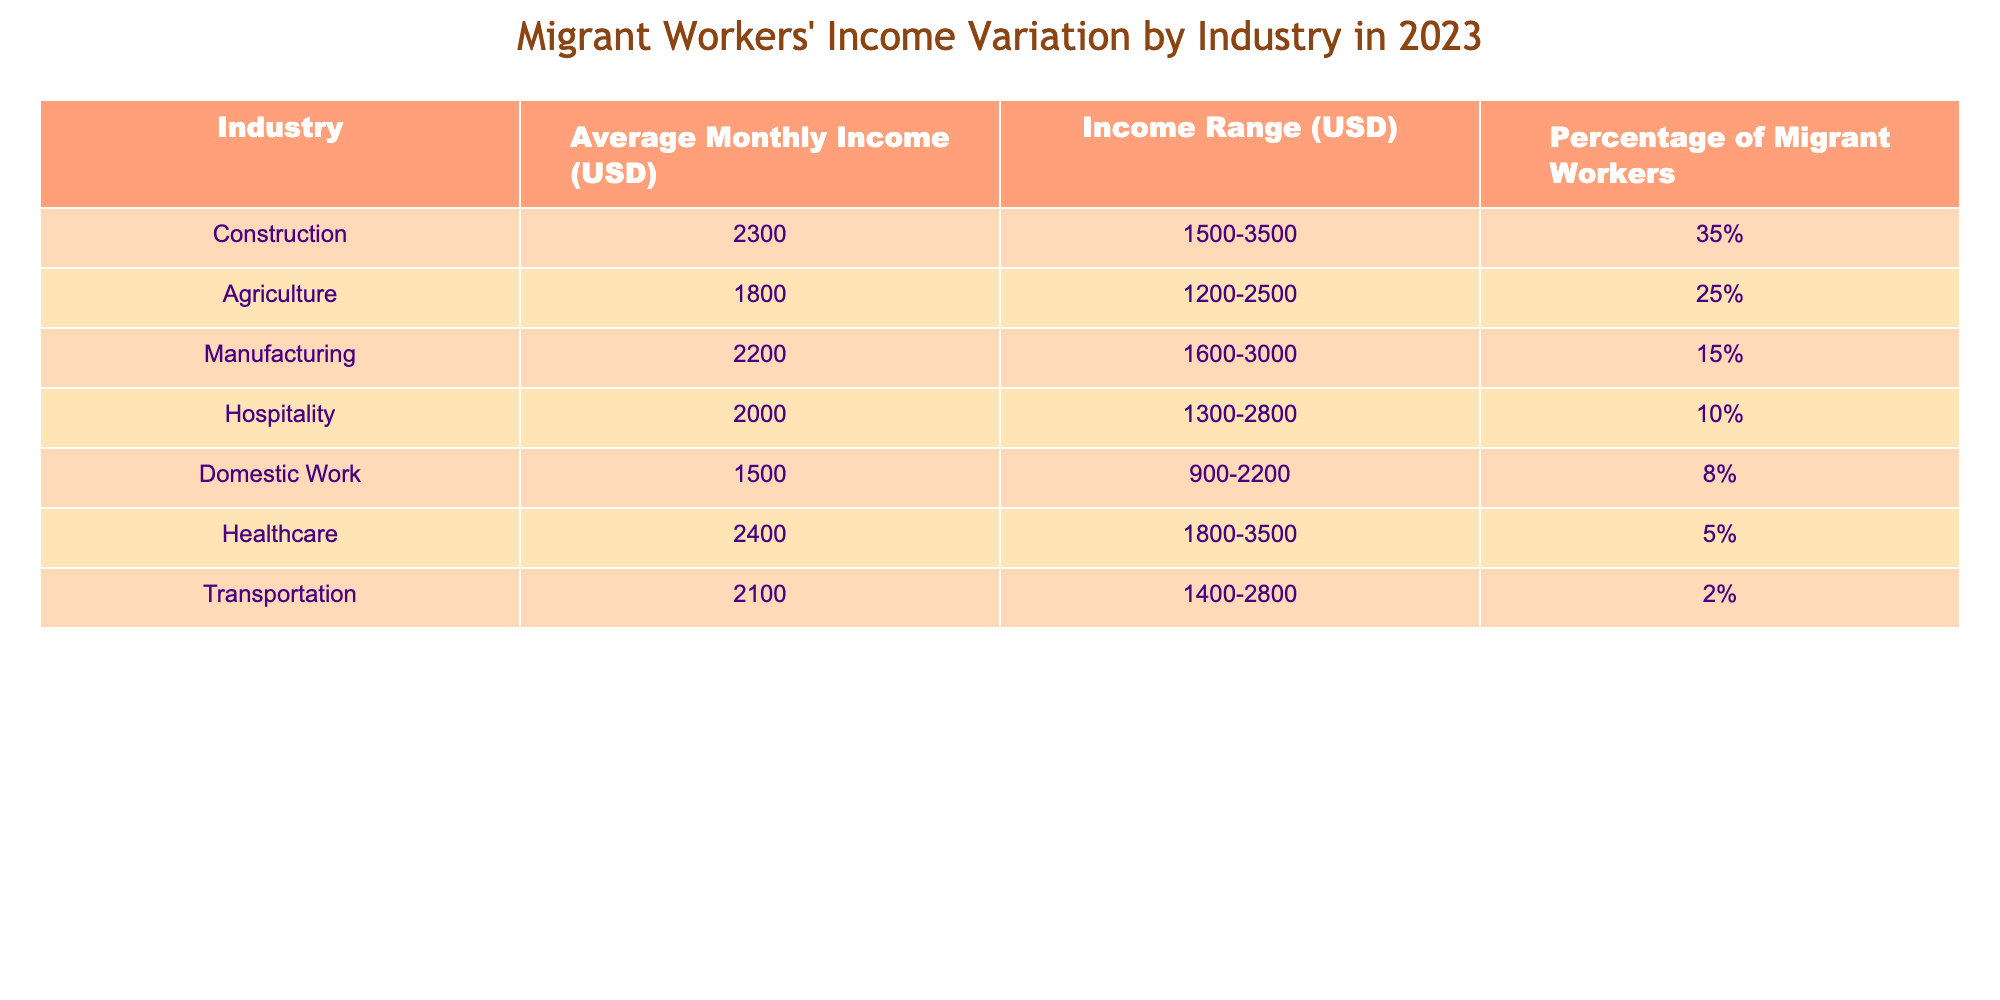What is the average monthly income for migrant workers in the Healthcare industry? The table shows that the average monthly income for migrant workers in the Healthcare industry is listed as 2400 USD.
Answer: 2400 USD Which industry has the highest percentage of migrant workers? Looking at the table, the industry with the highest percentage of migrant workers is Construction at 35%.
Answer: Construction What is the income range for workers in Domestic Work? The table specifies that the income range for workers in Domestic Work is between 900 to 2200 USD.
Answer: 900-2200 USD If we combine the percentages of migrant workers in Agriculture and Hospitality, what is the total percentage? The percentage of migrant workers in Agriculture is 25% and in Hospitality is 10%. Adding these percentages gives 25% + 10% = 35%.
Answer: 35% What is the income range for the Manufacturing industry? According to the table, the income range for the Manufacturing industry is from 1600 to 3000 USD.
Answer: 1600-3000 USD Is the average monthly income in Agriculture higher than in Domestic Work? The average monthly income in Agriculture is 1800 USD, and in Domestic Work, it is 1500 USD. Since 1800 > 1500, it is true that Agriculture has a higher income.
Answer: Yes What is the difference in average monthly income between the Healthcare and Construction industries? The average monthly income in Healthcare is 2400 USD and in Construction, it is 2300 USD. The difference is calculated as 2400 - 2300 = 100.
Answer: 100 USD Considering all industries, which one has the lowest average monthly income? The table indicates that the Domestic Work industry has the lowest average monthly income at 1500 USD.
Answer: Domestic Work Calculate the average income of all listed industries. The average is calculated by summing the monthly incomes: (2300 + 1800 + 2200 + 2000 + 1500 + 2400 + 2100) = 14500 USD. There are 7 industries, so the average is 14500 / 7 ≈ 2071.43 USD.
Answer: 2071.43 USD Are there more industries with an average income below 2000 USD than above 2000 USD? The industries below 2000 USD are Domestic Work (1500 USD) and Agriculture (1800 USD), totaling 2. Those above are Construction (2300 USD), Manufacturing (2200 USD), Hospitality (2000 USD), Healthcare (2400 USD), and Transportation (2100 USD) totaling 5. Thus, more industries have incomes above 2000 USD.
Answer: No 